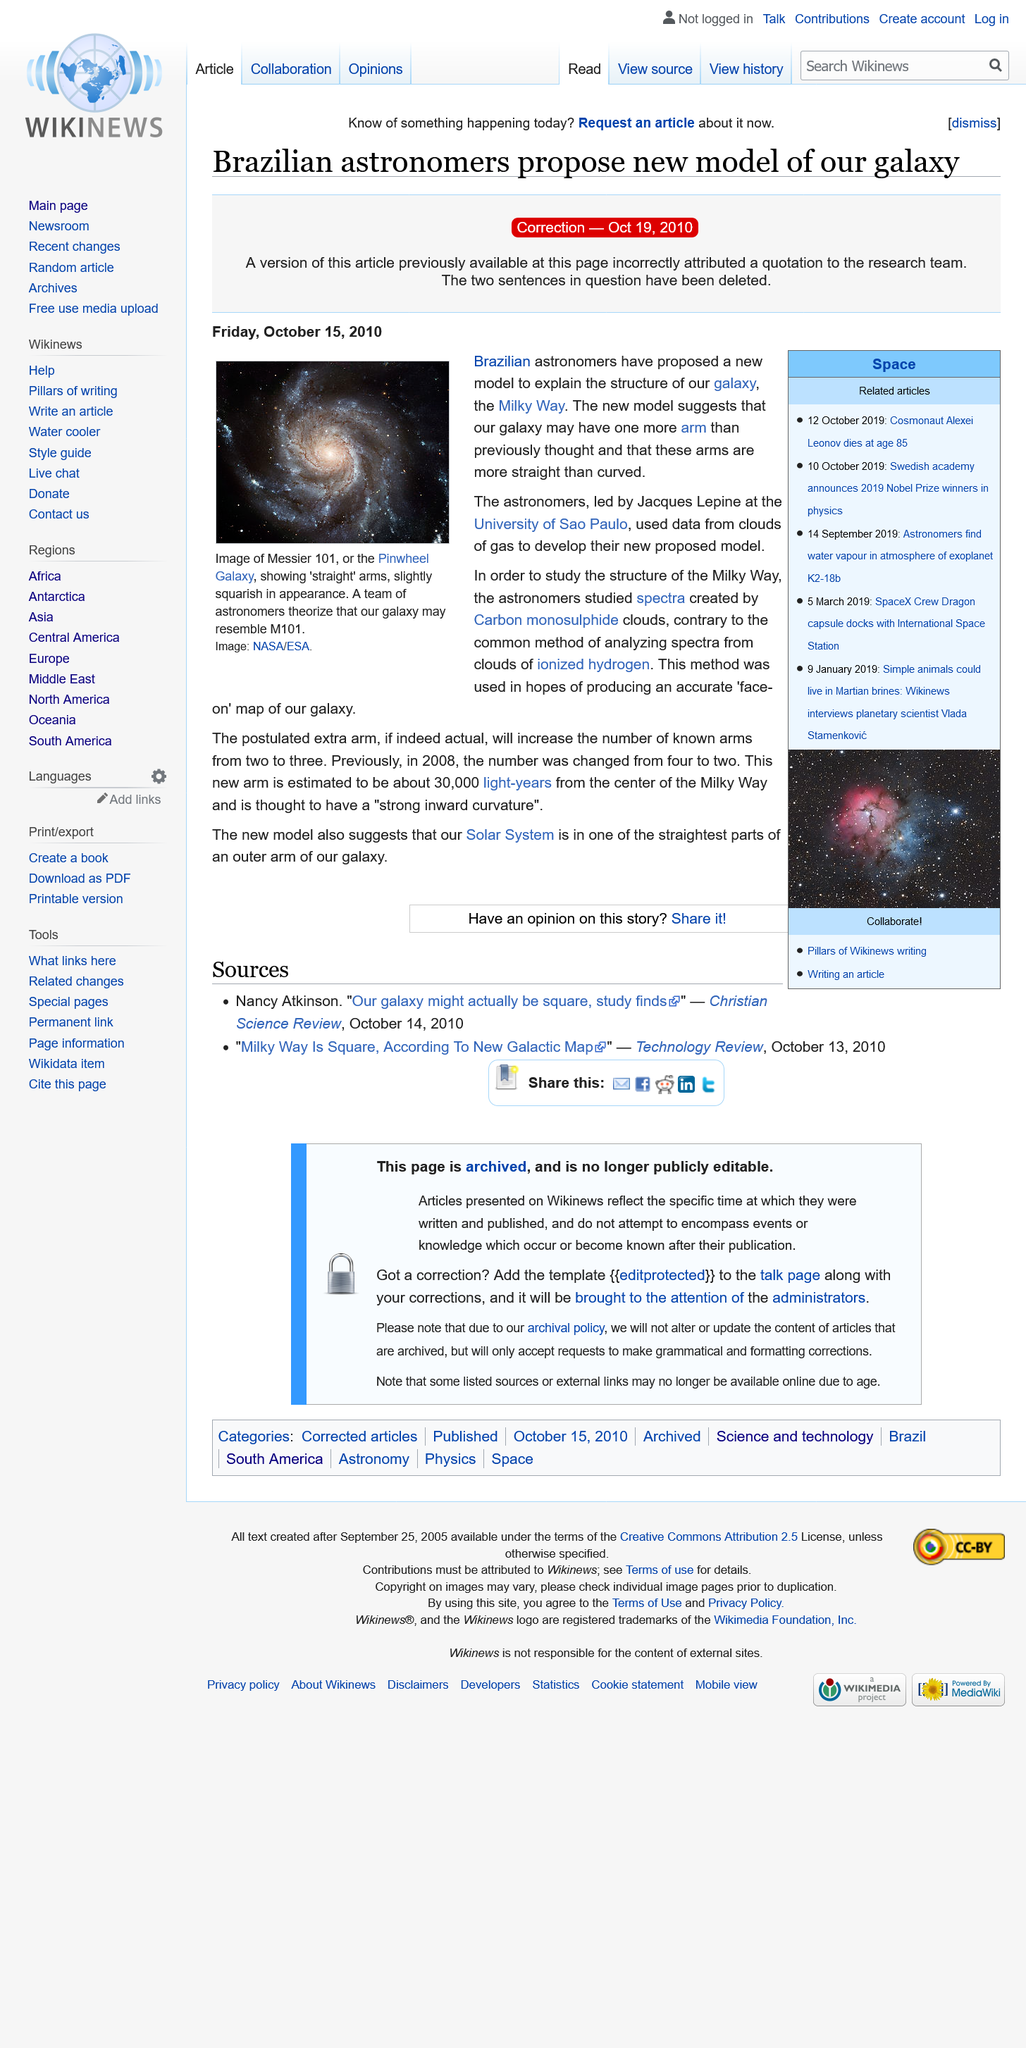Mention a couple of crucial points in this snapshot. The astronomers studied the spectra created by Carbon monosulphide clouds in order to gain a better understanding of the structure of the Milky Way. Under the leadership of Jacques Lepine, a team of astronomers from the University of Sao Paulo conducted their observations. The picture depicts Messier 101, also known as the Pinwheel Galaxy, which is a deep-sky object located in the constellation of Cetus. The galaxy is known for its distinctive spiral shape and bright center, which is visible in the image. The image itself is an illustration rather than a photograph, which highlights the intricate details of the galaxy and its surroundings. The use of color and texture adds to the overall visual impact of the image, making it a striking and awe-inspiring representation of one of the most famous galaxies in the sky. 